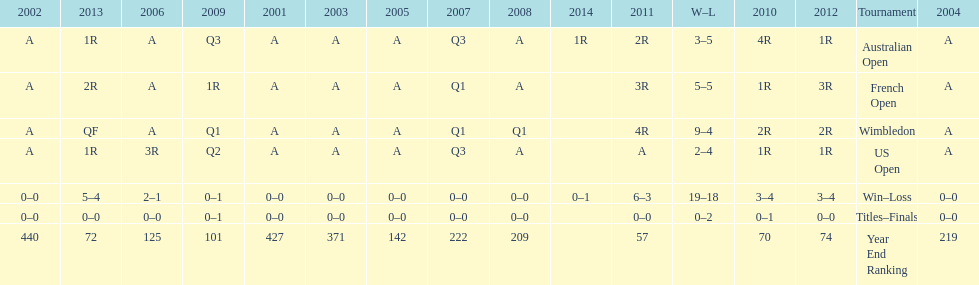What was the total number of matches played from 2001 to 2014? 37. 